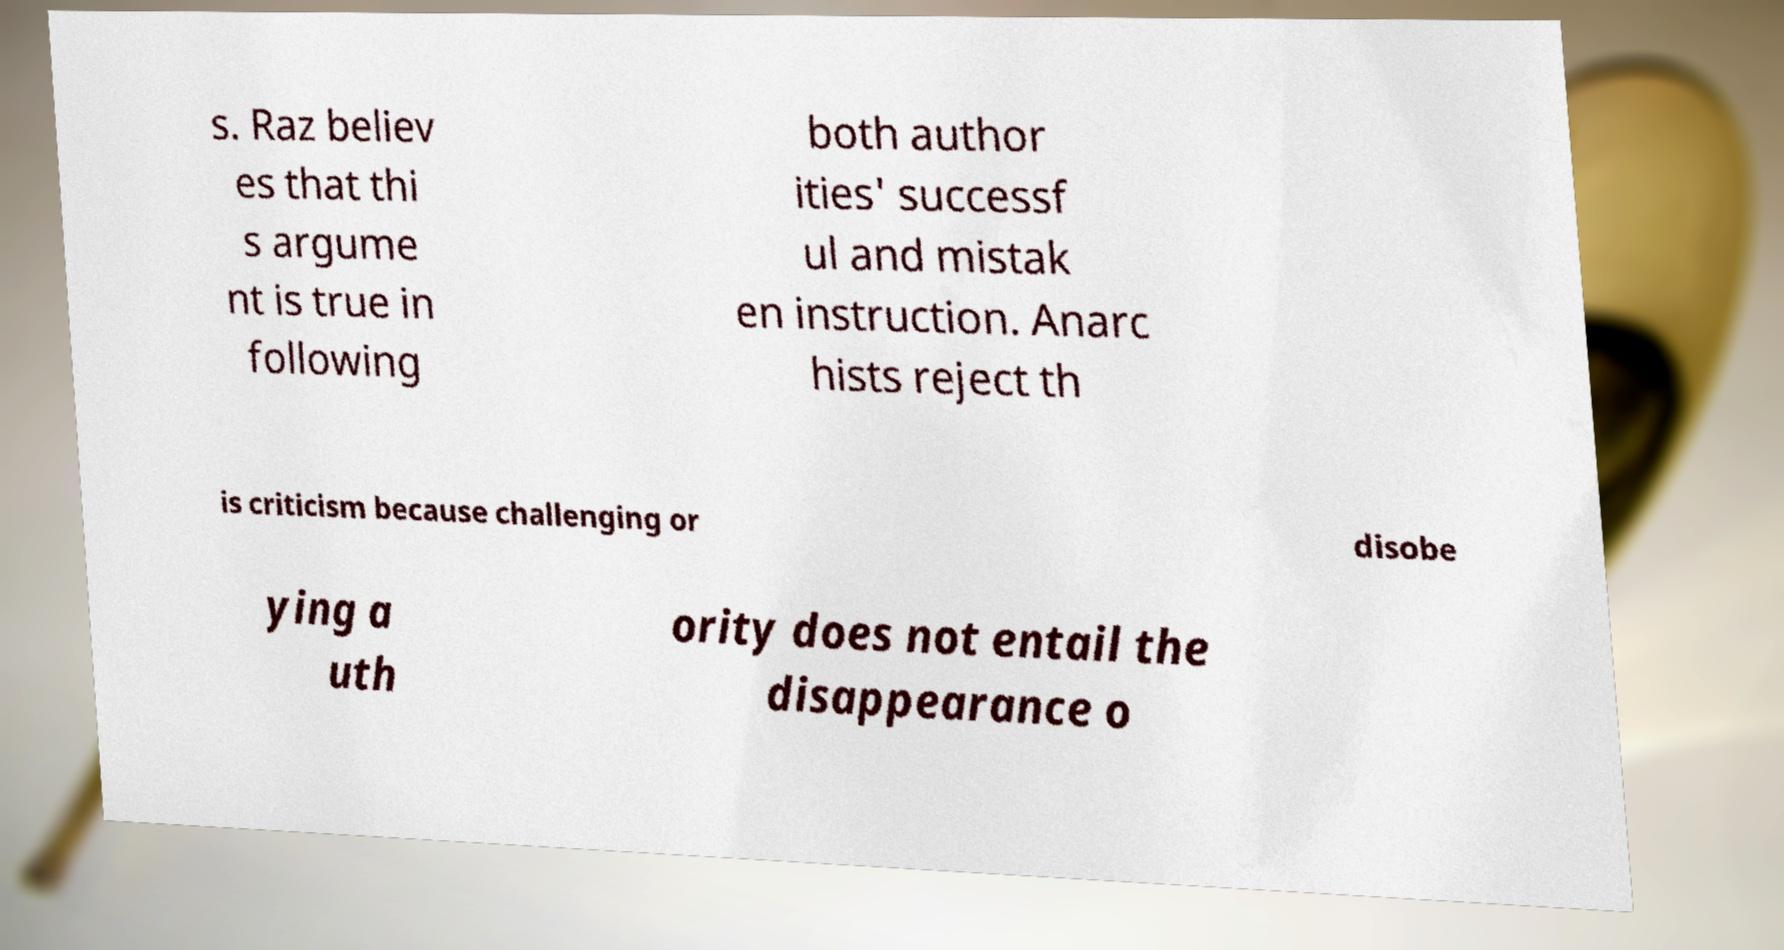Can you read and provide the text displayed in the image?This photo seems to have some interesting text. Can you extract and type it out for me? s. Raz believ es that thi s argume nt is true in following both author ities' successf ul and mistak en instruction. Anarc hists reject th is criticism because challenging or disobe ying a uth ority does not entail the disappearance o 